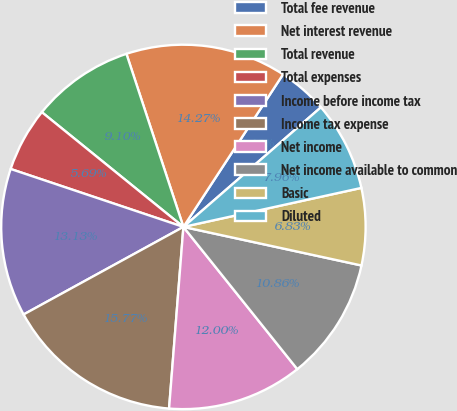<chart> <loc_0><loc_0><loc_500><loc_500><pie_chart><fcel>Total fee revenue<fcel>Net interest revenue<fcel>Total revenue<fcel>Total expenses<fcel>Income before income tax<fcel>Income tax expense<fcel>Net income<fcel>Net income available to common<fcel>Basic<fcel>Diluted<nl><fcel>4.4%<fcel>14.27%<fcel>9.1%<fcel>5.69%<fcel>13.13%<fcel>15.77%<fcel>12.0%<fcel>10.86%<fcel>6.83%<fcel>7.96%<nl></chart> 